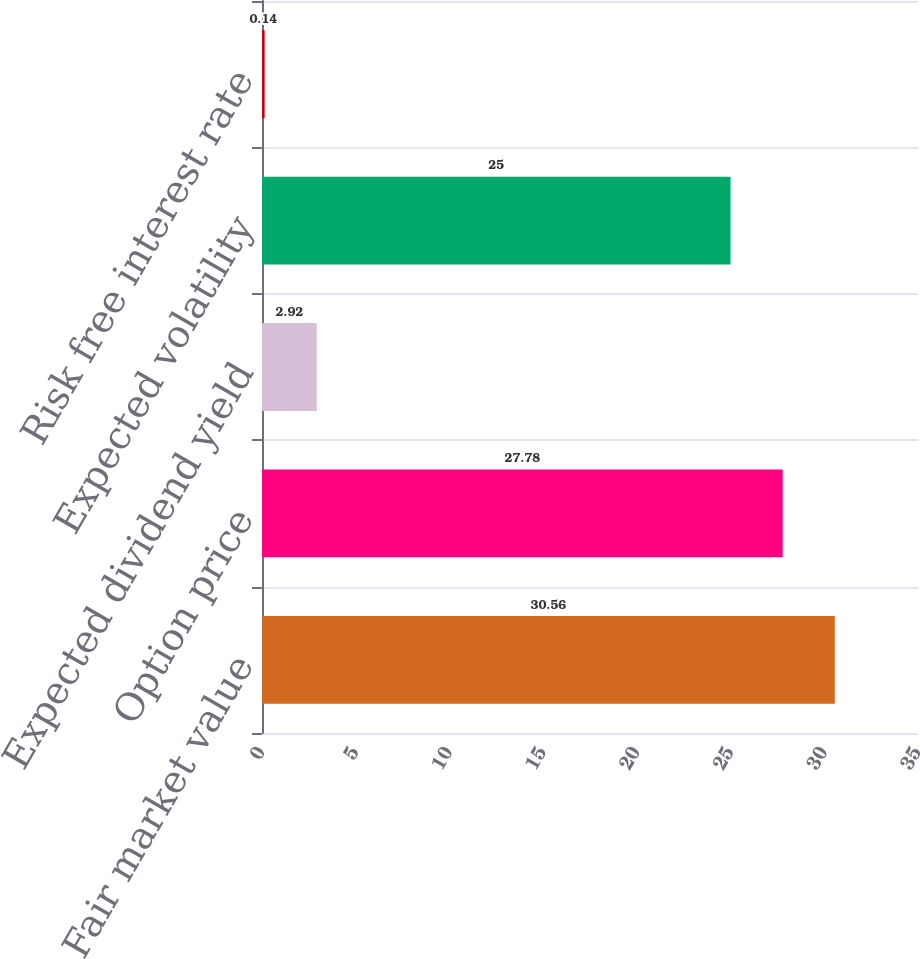Convert chart to OTSL. <chart><loc_0><loc_0><loc_500><loc_500><bar_chart><fcel>Fair market value<fcel>Option price<fcel>Expected dividend yield<fcel>Expected volatility<fcel>Risk free interest rate<nl><fcel>30.56<fcel>27.78<fcel>2.92<fcel>25<fcel>0.14<nl></chart> 